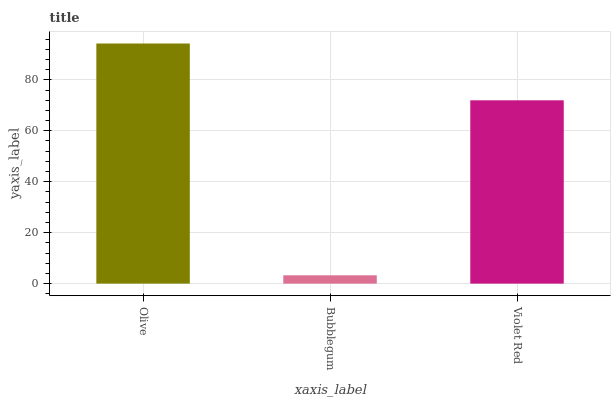Is Bubblegum the minimum?
Answer yes or no. Yes. Is Olive the maximum?
Answer yes or no. Yes. Is Violet Red the minimum?
Answer yes or no. No. Is Violet Red the maximum?
Answer yes or no. No. Is Violet Red greater than Bubblegum?
Answer yes or no. Yes. Is Bubblegum less than Violet Red?
Answer yes or no. Yes. Is Bubblegum greater than Violet Red?
Answer yes or no. No. Is Violet Red less than Bubblegum?
Answer yes or no. No. Is Violet Red the high median?
Answer yes or no. Yes. Is Violet Red the low median?
Answer yes or no. Yes. Is Olive the high median?
Answer yes or no. No. Is Bubblegum the low median?
Answer yes or no. No. 